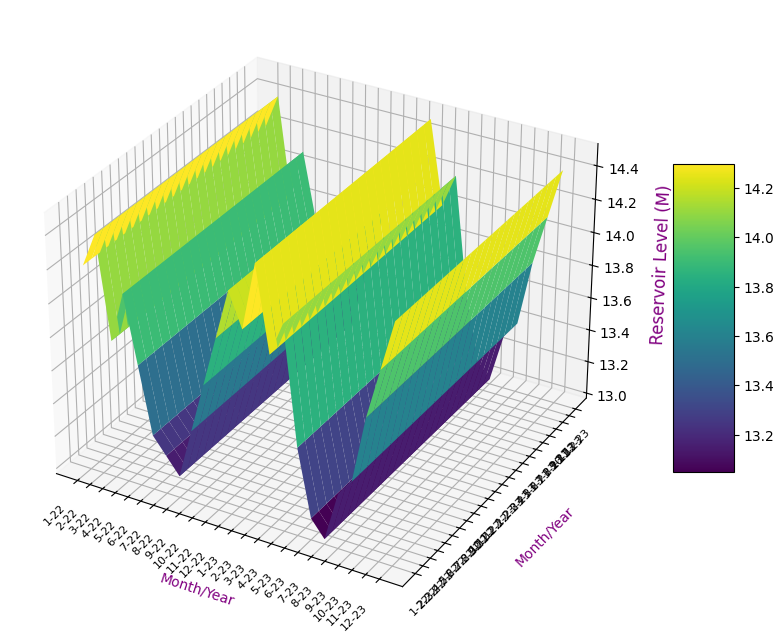What is the lowest reservoir level observed and in which month/year did it occur? Identify the lowest bar on the Z-axis, which corresponds to the lowest reservoir level, and then find the corresponding month/year on the X and Y axes.
Answer: 13.0 in July 2023 Which month/year has the highest average temperature observed? Look for the month/year with the highest point along the month/year axis that corresponds to the highest average temperature value.
Answer: July 2023 What is the median reservoir level for all observations? First, list all reservoir levels in ascending order, then find the middle value. Since there are 24 data points, the median will be the average of the 12th and 13th values in the sorted list.
Answer: 13.75 How much does the reservoir level increase from the lowest to the highest observed level? Identify both the lowest and highest reservoir levels from the Z-axis and then calculate the difference between them.
Answer: 1.4 (14.5 - 13.1) Is there any month/year where the reservoir level remains consistent with the previous month/year? Compare each consecutive data point along the Z-axis to see if any two consecutive months/years have the same reservoir level.
Answer: January 2022 and January 2023 both have 14.1 Does the reservoir level show any seasonality in trends? By observing the entire plot over the months/years and comparing it visually, note if there's any repeating pattern corresponding to seasons.
Answer: Generally higher in winter, lower in summer Which year shows a more significant variation in reservoir levels, 2022 or 2023? Compare the fluctuation range of reservoir levels for each year by observing the differences between the maximum and minimum levels within the year.
Answer: 2022 What is the average reservoir level for the summer months (June-August) in 2023? Find the reservoir levels for June, July, and August 2023, sum them up, then divide by 3.
Answer: 13.13 How does the reservoir level in November 2023 compare to November 2022? Compare the reservoir levels plotted for November 2022 and November 2023 by looking at the Z-values at these points.
Answer: Higher in 2023 (14.1 vs. 14.0) 